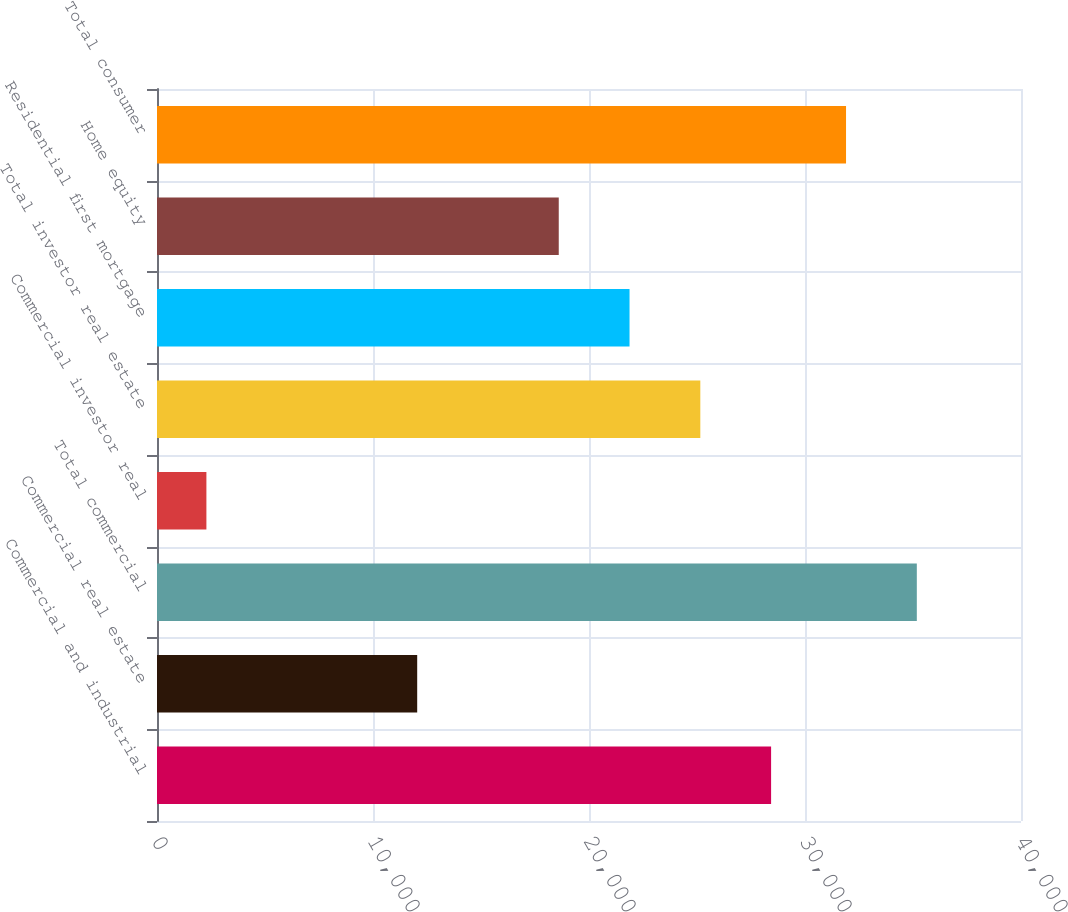<chart> <loc_0><loc_0><loc_500><loc_500><bar_chart><fcel>Commercial and industrial<fcel>Commercial real estate<fcel>Total commercial<fcel>Commercial investor real<fcel>Total investor real estate<fcel>Residential first mortgage<fcel>Home equity<fcel>Total consumer<nl><fcel>28430.5<fcel>12046<fcel>35176.9<fcel>2287<fcel>25153.6<fcel>21876.7<fcel>18599.8<fcel>31900<nl></chart> 